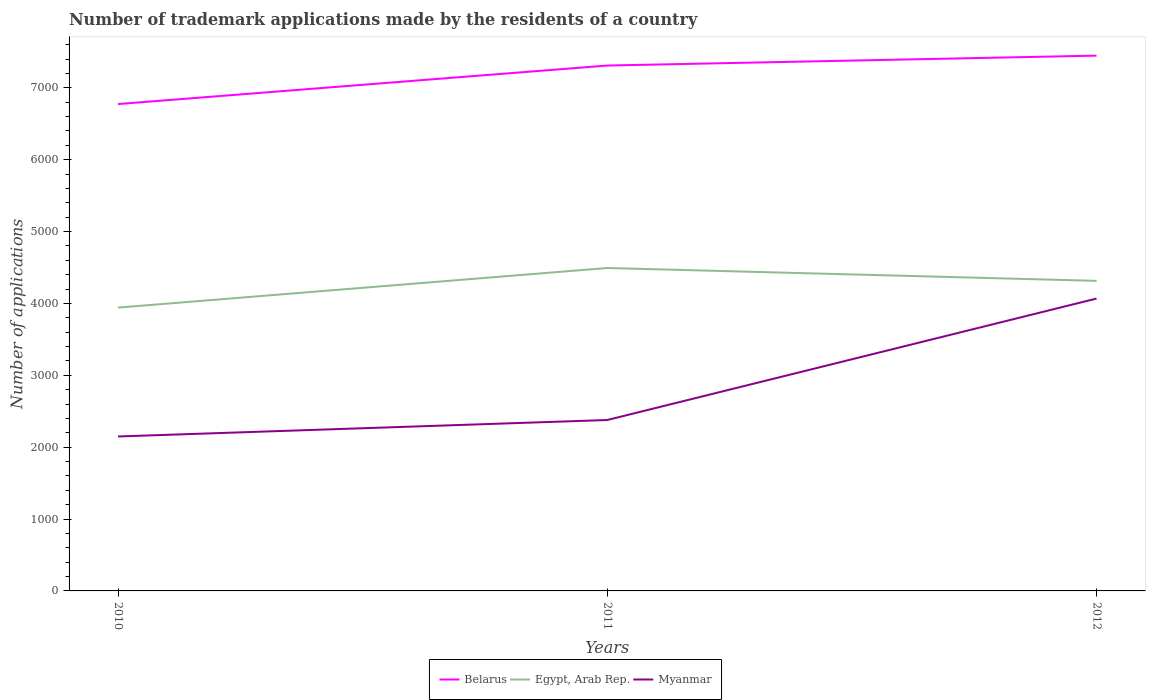Across all years, what is the maximum number of trademark applications made by the residents in Belarus?
Provide a succinct answer. 6774. What is the total number of trademark applications made by the residents in Egypt, Arab Rep. in the graph?
Ensure brevity in your answer.  -372. What is the difference between the highest and the second highest number of trademark applications made by the residents in Egypt, Arab Rep.?
Provide a short and direct response. 551. What is the difference between the highest and the lowest number of trademark applications made by the residents in Belarus?
Your response must be concise. 2. Is the number of trademark applications made by the residents in Belarus strictly greater than the number of trademark applications made by the residents in Myanmar over the years?
Give a very brief answer. No. How are the legend labels stacked?
Your response must be concise. Horizontal. What is the title of the graph?
Keep it short and to the point. Number of trademark applications made by the residents of a country. What is the label or title of the X-axis?
Offer a terse response. Years. What is the label or title of the Y-axis?
Give a very brief answer. Number of applications. What is the Number of applications in Belarus in 2010?
Provide a succinct answer. 6774. What is the Number of applications in Egypt, Arab Rep. in 2010?
Provide a succinct answer. 3942. What is the Number of applications in Myanmar in 2010?
Your answer should be compact. 2149. What is the Number of applications in Belarus in 2011?
Your response must be concise. 7310. What is the Number of applications of Egypt, Arab Rep. in 2011?
Your answer should be compact. 4493. What is the Number of applications of Myanmar in 2011?
Your answer should be very brief. 2378. What is the Number of applications in Belarus in 2012?
Make the answer very short. 7448. What is the Number of applications of Egypt, Arab Rep. in 2012?
Your answer should be very brief. 4314. What is the Number of applications in Myanmar in 2012?
Offer a very short reply. 4068. Across all years, what is the maximum Number of applications in Belarus?
Give a very brief answer. 7448. Across all years, what is the maximum Number of applications in Egypt, Arab Rep.?
Your response must be concise. 4493. Across all years, what is the maximum Number of applications of Myanmar?
Provide a short and direct response. 4068. Across all years, what is the minimum Number of applications of Belarus?
Keep it short and to the point. 6774. Across all years, what is the minimum Number of applications of Egypt, Arab Rep.?
Offer a very short reply. 3942. Across all years, what is the minimum Number of applications in Myanmar?
Offer a very short reply. 2149. What is the total Number of applications of Belarus in the graph?
Your response must be concise. 2.15e+04. What is the total Number of applications in Egypt, Arab Rep. in the graph?
Your response must be concise. 1.27e+04. What is the total Number of applications in Myanmar in the graph?
Make the answer very short. 8595. What is the difference between the Number of applications in Belarus in 2010 and that in 2011?
Ensure brevity in your answer.  -536. What is the difference between the Number of applications of Egypt, Arab Rep. in 2010 and that in 2011?
Make the answer very short. -551. What is the difference between the Number of applications of Myanmar in 2010 and that in 2011?
Your answer should be compact. -229. What is the difference between the Number of applications of Belarus in 2010 and that in 2012?
Offer a very short reply. -674. What is the difference between the Number of applications in Egypt, Arab Rep. in 2010 and that in 2012?
Provide a short and direct response. -372. What is the difference between the Number of applications of Myanmar in 2010 and that in 2012?
Provide a succinct answer. -1919. What is the difference between the Number of applications in Belarus in 2011 and that in 2012?
Make the answer very short. -138. What is the difference between the Number of applications in Egypt, Arab Rep. in 2011 and that in 2012?
Offer a very short reply. 179. What is the difference between the Number of applications of Myanmar in 2011 and that in 2012?
Ensure brevity in your answer.  -1690. What is the difference between the Number of applications in Belarus in 2010 and the Number of applications in Egypt, Arab Rep. in 2011?
Your answer should be compact. 2281. What is the difference between the Number of applications of Belarus in 2010 and the Number of applications of Myanmar in 2011?
Your answer should be very brief. 4396. What is the difference between the Number of applications of Egypt, Arab Rep. in 2010 and the Number of applications of Myanmar in 2011?
Your response must be concise. 1564. What is the difference between the Number of applications in Belarus in 2010 and the Number of applications in Egypt, Arab Rep. in 2012?
Provide a succinct answer. 2460. What is the difference between the Number of applications in Belarus in 2010 and the Number of applications in Myanmar in 2012?
Your answer should be compact. 2706. What is the difference between the Number of applications of Egypt, Arab Rep. in 2010 and the Number of applications of Myanmar in 2012?
Give a very brief answer. -126. What is the difference between the Number of applications in Belarus in 2011 and the Number of applications in Egypt, Arab Rep. in 2012?
Make the answer very short. 2996. What is the difference between the Number of applications of Belarus in 2011 and the Number of applications of Myanmar in 2012?
Give a very brief answer. 3242. What is the difference between the Number of applications in Egypt, Arab Rep. in 2011 and the Number of applications in Myanmar in 2012?
Offer a very short reply. 425. What is the average Number of applications of Belarus per year?
Keep it short and to the point. 7177.33. What is the average Number of applications in Egypt, Arab Rep. per year?
Offer a very short reply. 4249.67. What is the average Number of applications in Myanmar per year?
Your answer should be compact. 2865. In the year 2010, what is the difference between the Number of applications in Belarus and Number of applications in Egypt, Arab Rep.?
Your answer should be very brief. 2832. In the year 2010, what is the difference between the Number of applications in Belarus and Number of applications in Myanmar?
Offer a terse response. 4625. In the year 2010, what is the difference between the Number of applications in Egypt, Arab Rep. and Number of applications in Myanmar?
Provide a succinct answer. 1793. In the year 2011, what is the difference between the Number of applications in Belarus and Number of applications in Egypt, Arab Rep.?
Give a very brief answer. 2817. In the year 2011, what is the difference between the Number of applications of Belarus and Number of applications of Myanmar?
Your answer should be compact. 4932. In the year 2011, what is the difference between the Number of applications in Egypt, Arab Rep. and Number of applications in Myanmar?
Your response must be concise. 2115. In the year 2012, what is the difference between the Number of applications of Belarus and Number of applications of Egypt, Arab Rep.?
Make the answer very short. 3134. In the year 2012, what is the difference between the Number of applications in Belarus and Number of applications in Myanmar?
Keep it short and to the point. 3380. In the year 2012, what is the difference between the Number of applications of Egypt, Arab Rep. and Number of applications of Myanmar?
Ensure brevity in your answer.  246. What is the ratio of the Number of applications of Belarus in 2010 to that in 2011?
Make the answer very short. 0.93. What is the ratio of the Number of applications in Egypt, Arab Rep. in 2010 to that in 2011?
Your answer should be very brief. 0.88. What is the ratio of the Number of applications in Myanmar in 2010 to that in 2011?
Provide a succinct answer. 0.9. What is the ratio of the Number of applications in Belarus in 2010 to that in 2012?
Give a very brief answer. 0.91. What is the ratio of the Number of applications of Egypt, Arab Rep. in 2010 to that in 2012?
Offer a terse response. 0.91. What is the ratio of the Number of applications of Myanmar in 2010 to that in 2012?
Keep it short and to the point. 0.53. What is the ratio of the Number of applications of Belarus in 2011 to that in 2012?
Give a very brief answer. 0.98. What is the ratio of the Number of applications of Egypt, Arab Rep. in 2011 to that in 2012?
Keep it short and to the point. 1.04. What is the ratio of the Number of applications of Myanmar in 2011 to that in 2012?
Your answer should be compact. 0.58. What is the difference between the highest and the second highest Number of applications in Belarus?
Your answer should be very brief. 138. What is the difference between the highest and the second highest Number of applications in Egypt, Arab Rep.?
Your response must be concise. 179. What is the difference between the highest and the second highest Number of applications of Myanmar?
Provide a short and direct response. 1690. What is the difference between the highest and the lowest Number of applications of Belarus?
Ensure brevity in your answer.  674. What is the difference between the highest and the lowest Number of applications in Egypt, Arab Rep.?
Your response must be concise. 551. What is the difference between the highest and the lowest Number of applications of Myanmar?
Ensure brevity in your answer.  1919. 